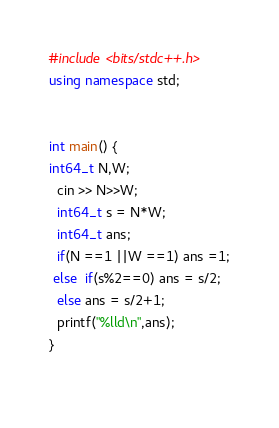Convert code to text. <code><loc_0><loc_0><loc_500><loc_500><_C++_>#include <bits/stdc++.h>
using namespace std;


int main() {
int64_t N,W;
  cin >> N>>W;
  int64_t s = N*W;
  int64_t ans;
  if(N ==1 ||W ==1) ans =1;
 else  if(s%2==0) ans = s/2;
  else ans = s/2+1;
  printf("%lld\n",ans);
}
  
</code> 